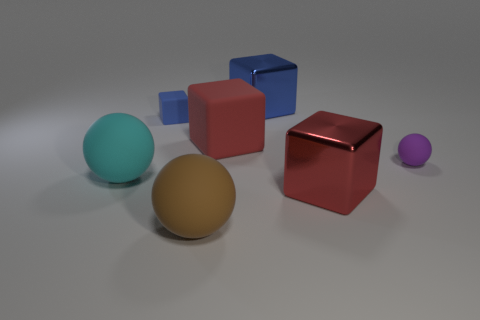Subtract all green cubes. Subtract all green cylinders. How many cubes are left? 4 Add 2 large red metal cubes. How many objects exist? 9 Subtract all cubes. How many objects are left? 3 Add 4 red cubes. How many red cubes exist? 6 Subtract 0 yellow cylinders. How many objects are left? 7 Subtract all tiny gray objects. Subtract all tiny purple matte things. How many objects are left? 6 Add 6 brown balls. How many brown balls are left? 7 